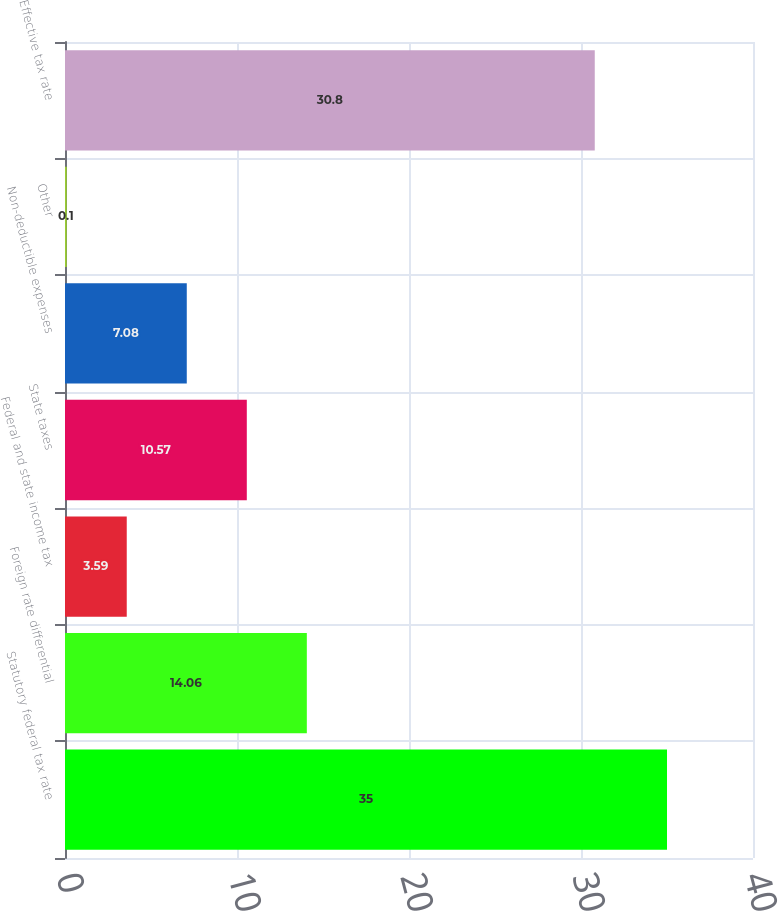Convert chart. <chart><loc_0><loc_0><loc_500><loc_500><bar_chart><fcel>Statutory federal tax rate<fcel>Foreign rate differential<fcel>Federal and state income tax<fcel>State taxes<fcel>Non-deductible expenses<fcel>Other<fcel>Effective tax rate<nl><fcel>35<fcel>14.06<fcel>3.59<fcel>10.57<fcel>7.08<fcel>0.1<fcel>30.8<nl></chart> 